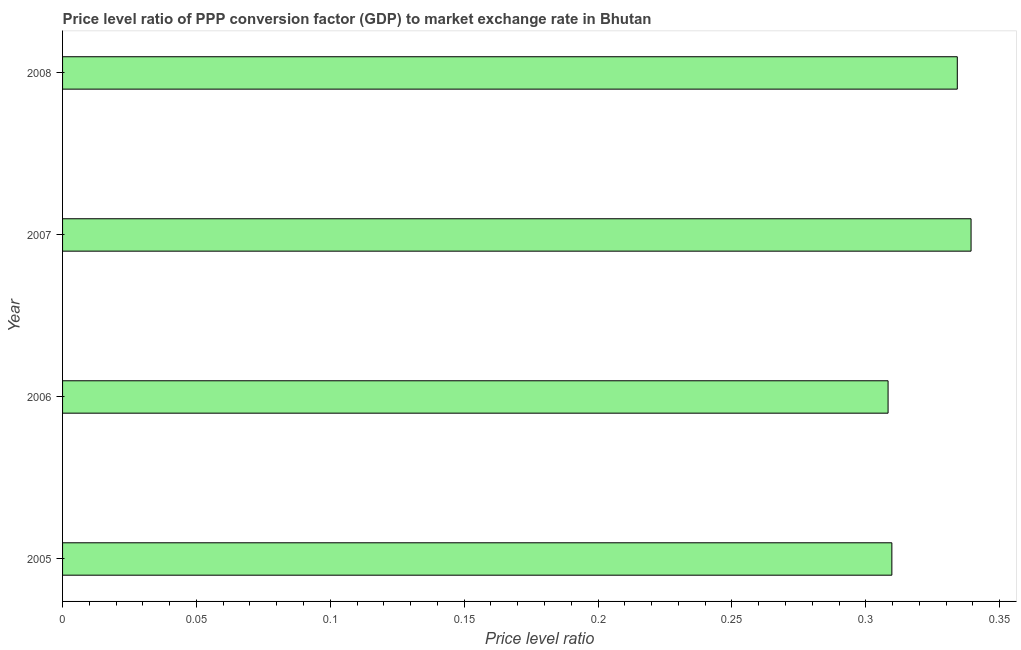What is the title of the graph?
Provide a short and direct response. Price level ratio of PPP conversion factor (GDP) to market exchange rate in Bhutan. What is the label or title of the X-axis?
Offer a very short reply. Price level ratio. What is the price level ratio in 2007?
Your answer should be compact. 0.34. Across all years, what is the maximum price level ratio?
Your answer should be compact. 0.34. Across all years, what is the minimum price level ratio?
Make the answer very short. 0.31. In which year was the price level ratio maximum?
Keep it short and to the point. 2007. In which year was the price level ratio minimum?
Offer a very short reply. 2006. What is the sum of the price level ratio?
Keep it short and to the point. 1.29. What is the difference between the price level ratio in 2005 and 2007?
Your answer should be very brief. -0.03. What is the average price level ratio per year?
Give a very brief answer. 0.32. What is the median price level ratio?
Offer a terse response. 0.32. Do a majority of the years between 2008 and 2005 (inclusive) have price level ratio greater than 0.03 ?
Offer a terse response. Yes. What is the ratio of the price level ratio in 2006 to that in 2007?
Offer a very short reply. 0.91. What is the difference between the highest and the second highest price level ratio?
Provide a short and direct response. 0.01. What is the difference between the highest and the lowest price level ratio?
Offer a very short reply. 0.03. Are all the bars in the graph horizontal?
Offer a terse response. Yes. How many years are there in the graph?
Your response must be concise. 4. What is the Price level ratio of 2005?
Your answer should be very brief. 0.31. What is the Price level ratio of 2006?
Your response must be concise. 0.31. What is the Price level ratio of 2007?
Ensure brevity in your answer.  0.34. What is the Price level ratio of 2008?
Provide a succinct answer. 0.33. What is the difference between the Price level ratio in 2005 and 2006?
Offer a terse response. 0. What is the difference between the Price level ratio in 2005 and 2007?
Your answer should be very brief. -0.03. What is the difference between the Price level ratio in 2005 and 2008?
Your answer should be compact. -0.02. What is the difference between the Price level ratio in 2006 and 2007?
Ensure brevity in your answer.  -0.03. What is the difference between the Price level ratio in 2006 and 2008?
Provide a short and direct response. -0.03. What is the difference between the Price level ratio in 2007 and 2008?
Provide a short and direct response. 0.01. What is the ratio of the Price level ratio in 2005 to that in 2006?
Your answer should be very brief. 1. What is the ratio of the Price level ratio in 2005 to that in 2008?
Make the answer very short. 0.93. What is the ratio of the Price level ratio in 2006 to that in 2007?
Keep it short and to the point. 0.91. What is the ratio of the Price level ratio in 2006 to that in 2008?
Make the answer very short. 0.92. What is the ratio of the Price level ratio in 2007 to that in 2008?
Offer a terse response. 1.01. 